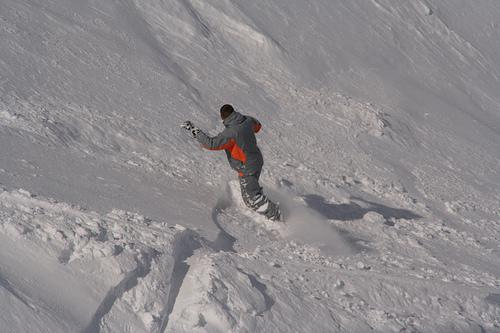Question: who is wearing grey and orange jacket?
Choices:
A. Person skiing.
B. Person skating.
C. Person snowboarding.
D. Person walking.
Answer with the letter. Answer: C Question: what is helping to light photo?
Choices:
A. Lighting.
B. Sun.
C. Flash.
D. Moon.
Answer with the letter. Answer: B Question: where was the photo taken?
Choices:
A. Grassy knoll.
B. Forested hill.
C. Snowy mountain.
D. Muddy field.
Answer with the letter. Answer: C Question: why is snowboarder wearing thick clothing?
Choices:
A. It's cold.
B. For safety.
C. To stay warm.
D. To protect themselves.
Answer with the letter. Answer: A 